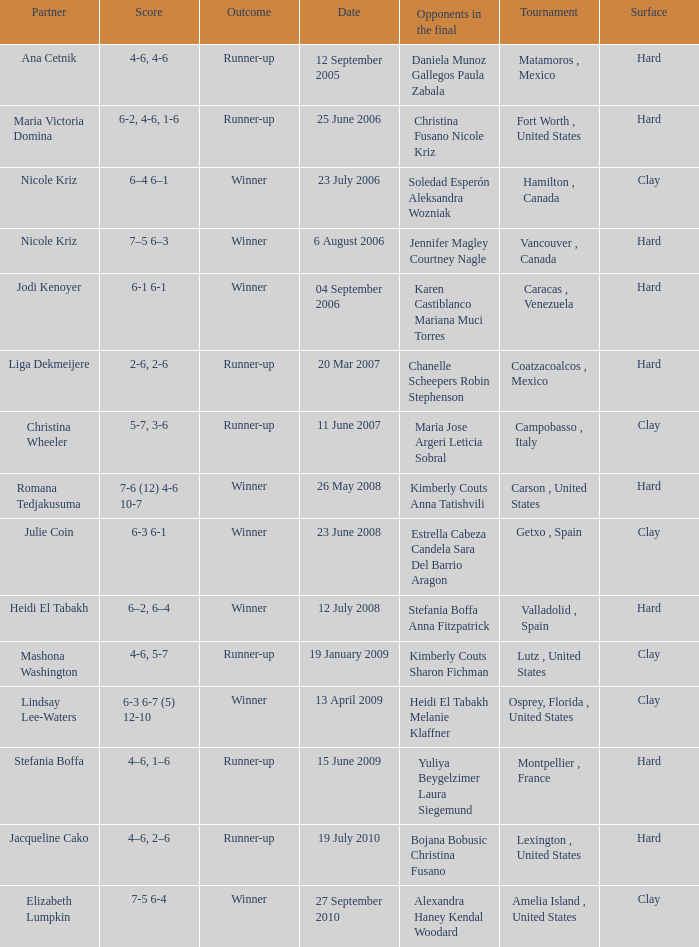Give me the full table as a dictionary. {'header': ['Partner', 'Score', 'Outcome', 'Date', 'Opponents in the final', 'Tournament', 'Surface'], 'rows': [['Ana Cetnik', '4-6, 4-6', 'Runner-up', '12 September 2005', 'Daniela Munoz Gallegos Paula Zabala', 'Matamoros , Mexico', 'Hard'], ['Maria Victoria Domina', '6-2, 4-6, 1-6', 'Runner-up', '25 June 2006', 'Christina Fusano Nicole Kriz', 'Fort Worth , United States', 'Hard'], ['Nicole Kriz', '6–4 6–1', 'Winner', '23 July 2006', 'Soledad Esperón Aleksandra Wozniak', 'Hamilton , Canada', 'Clay'], ['Nicole Kriz', '7–5 6–3', 'Winner', '6 August 2006', 'Jennifer Magley Courtney Nagle', 'Vancouver , Canada', 'Hard'], ['Jodi Kenoyer', '6-1 6-1', 'Winner', '04 September 2006', 'Karen Castiblanco Mariana Muci Torres', 'Caracas , Venezuela', 'Hard'], ['Liga Dekmeijere', '2-6, 2-6', 'Runner-up', '20 Mar 2007', 'Chanelle Scheepers Robin Stephenson', 'Coatzacoalcos , Mexico', 'Hard'], ['Christina Wheeler', '5-7, 3-6', 'Runner-up', '11 June 2007', 'Maria Jose Argeri Leticia Sobral', 'Campobasso , Italy', 'Clay'], ['Romana Tedjakusuma', '7-6 (12) 4-6 10-7', 'Winner', '26 May 2008', 'Kimberly Couts Anna Tatishvili', 'Carson , United States', 'Hard'], ['Julie Coin', '6-3 6-1', 'Winner', '23 June 2008', 'Estrella Cabeza Candela Sara Del Barrio Aragon', 'Getxo , Spain', 'Clay'], ['Heidi El Tabakh', '6–2, 6–4', 'Winner', '12 July 2008', 'Stefania Boffa Anna Fitzpatrick', 'Valladolid , Spain', 'Hard'], ['Mashona Washington', '4-6, 5-7', 'Runner-up', '19 January 2009', 'Kimberly Couts Sharon Fichman', 'Lutz , United States', 'Clay'], ['Lindsay Lee-Waters', '6-3 6-7 (5) 12-10', 'Winner', '13 April 2009', 'Heidi El Tabakh Melanie Klaffner', 'Osprey, Florida , United States', 'Clay'], ['Stefania Boffa', '4–6, 1–6', 'Runner-up', '15 June 2009', 'Yuliya Beygelzimer Laura Siegemund', 'Montpellier , France', 'Hard'], ['Jacqueline Cako', '4–6, 2–6', 'Runner-up', '19 July 2010', 'Bojana Bobusic Christina Fusano', 'Lexington , United States', 'Hard'], ['Elizabeth Lumpkin', '7-5 6-4', 'Winner', '27 September 2010', 'Alexandra Haney Kendal Woodard', 'Amelia Island , United States', 'Clay']]} What was the date for the match where Tweedie-Yates' partner was jodi kenoyer? 04 September 2006. 